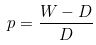Convert formula to latex. <formula><loc_0><loc_0><loc_500><loc_500>p = \frac { W - D } { D }</formula> 